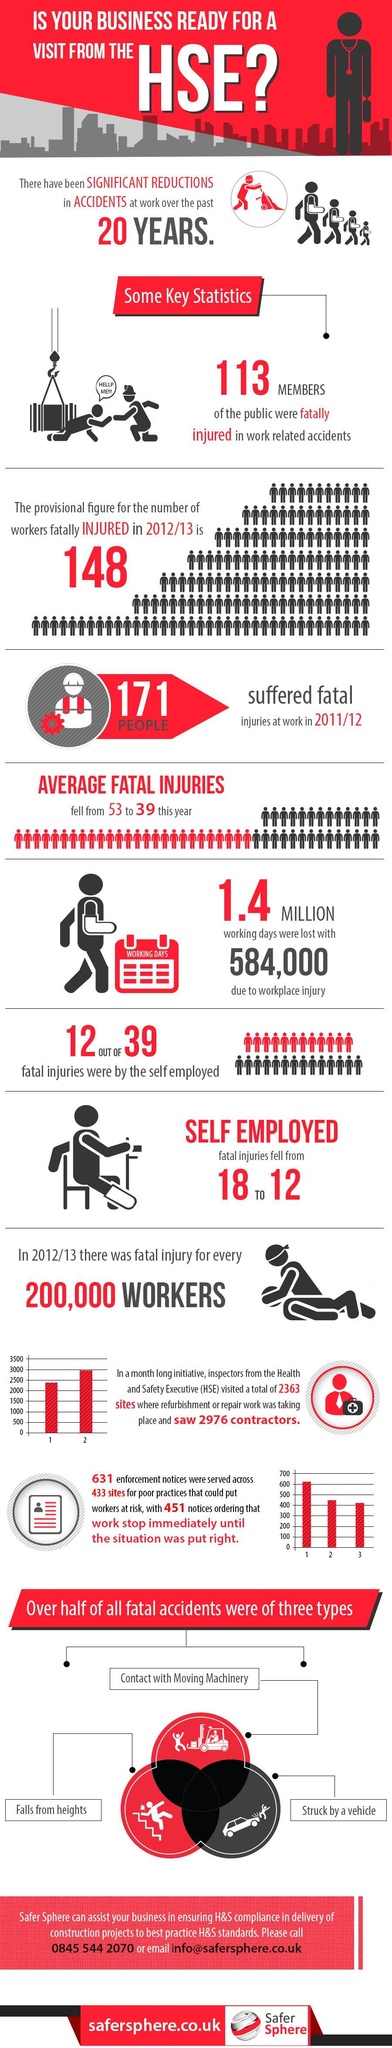What were the main reasons for more than half of all fatal accidents?
Answer the question with a short phrase. Contact with Moving Machinery, Falls from heights, Struck by a vehicle By what number did the average fatal injuries fall this year? 14 What number of injuries were not by the self employed? 27 OUT OF 39 